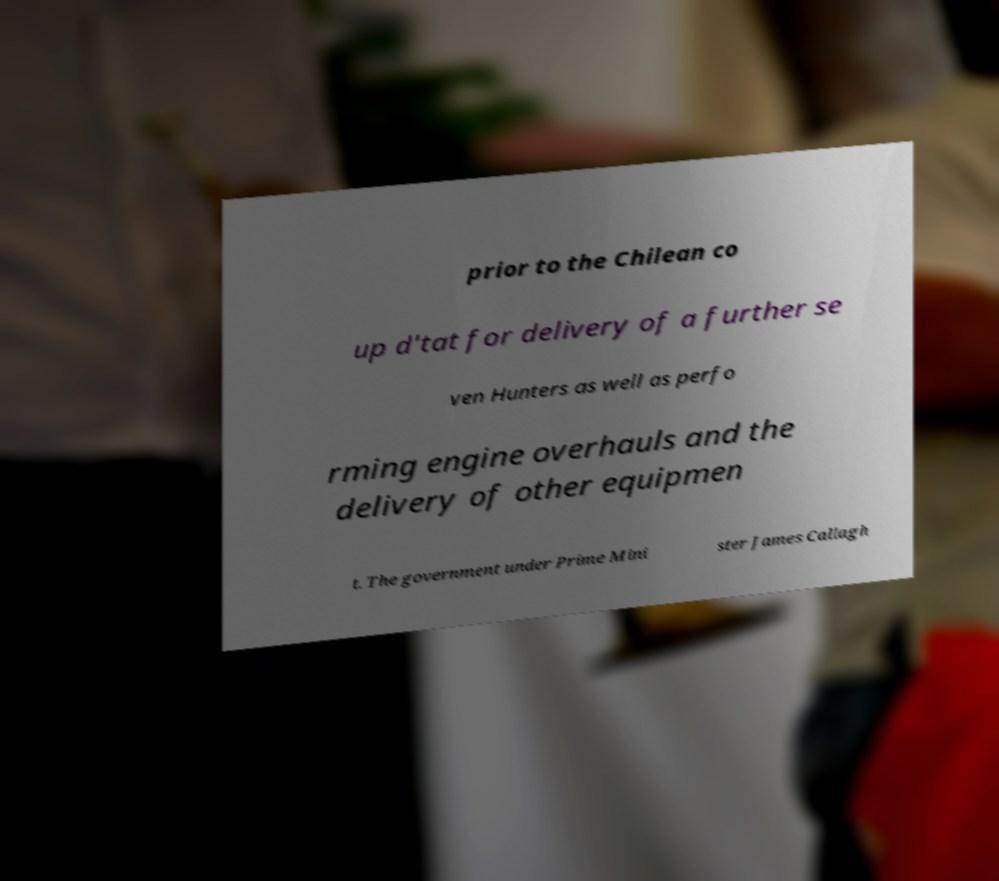I need the written content from this picture converted into text. Can you do that? prior to the Chilean co up d'tat for delivery of a further se ven Hunters as well as perfo rming engine overhauls and the delivery of other equipmen t. The government under Prime Mini ster James Callagh 